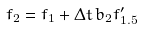<formula> <loc_0><loc_0><loc_500><loc_500>f _ { 2 } = f _ { 1 } + \Delta t \, b _ { 2 } f ^ { \prime } _ { 1 . 5 }</formula> 